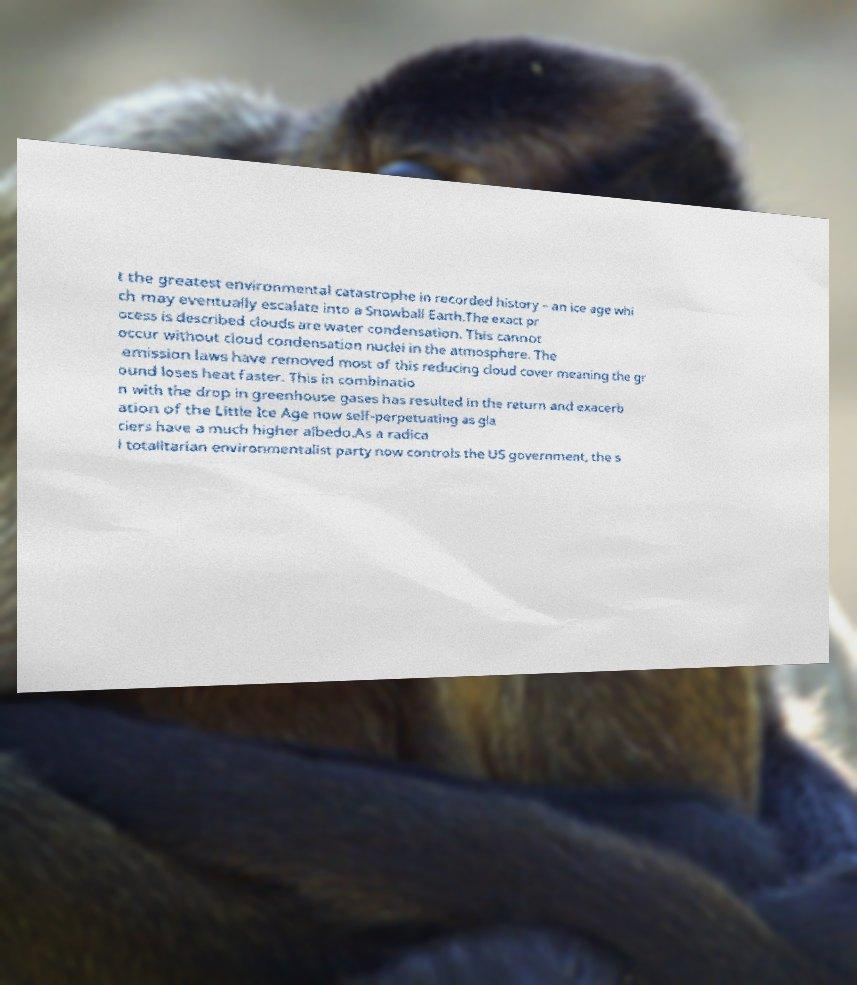There's text embedded in this image that I need extracted. Can you transcribe it verbatim? t the greatest environmental catastrophe in recorded history – an ice age whi ch may eventually escalate into a Snowball Earth.The exact pr ocess is described clouds are water condensation. This cannot occur without cloud condensation nuclei in the atmosphere. The emission laws have removed most of this reducing cloud cover meaning the gr ound loses heat faster. This in combinatio n with the drop in greenhouse gases has resulted in the return and exacerb ation of the Little Ice Age now self-perpetuating as gla ciers have a much higher albedo.As a radica l totalitarian environmentalist party now controls the US government, the s 